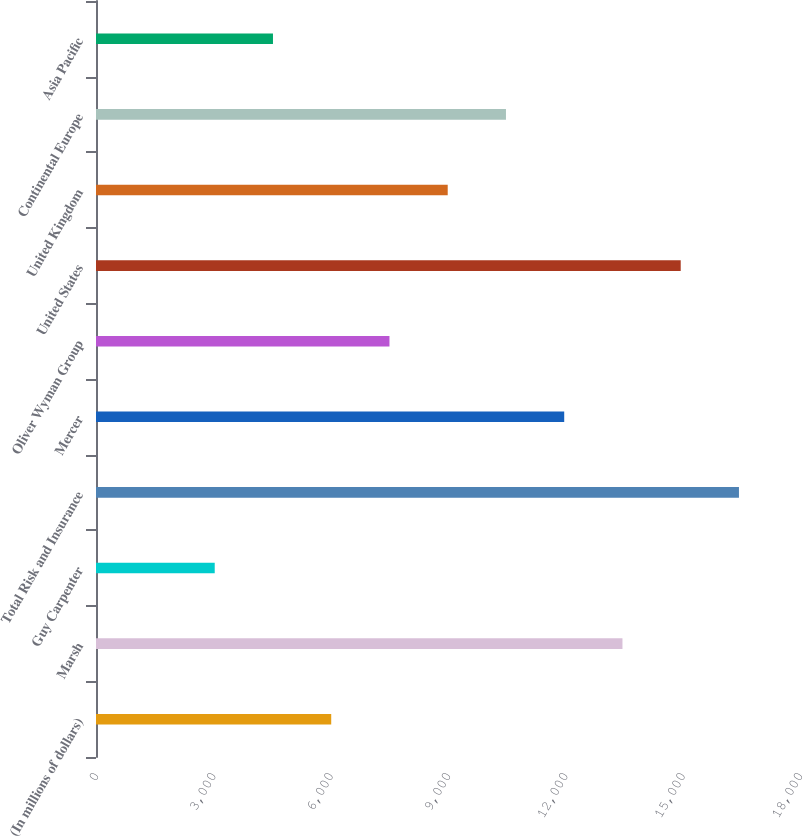Convert chart to OTSL. <chart><loc_0><loc_0><loc_500><loc_500><bar_chart><fcel>(In millions of dollars)<fcel>Marsh<fcel>Guy Carpenter<fcel>Total Risk and Insurance<fcel>Mercer<fcel>Oliver Wyman Group<fcel>United States<fcel>United Kingdom<fcel>Continental Europe<fcel>Asia Pacific<nl><fcel>6014.2<fcel>13460.7<fcel>3035.6<fcel>16439.3<fcel>11971.4<fcel>7503.5<fcel>14950<fcel>8992.8<fcel>10482.1<fcel>4524.9<nl></chart> 